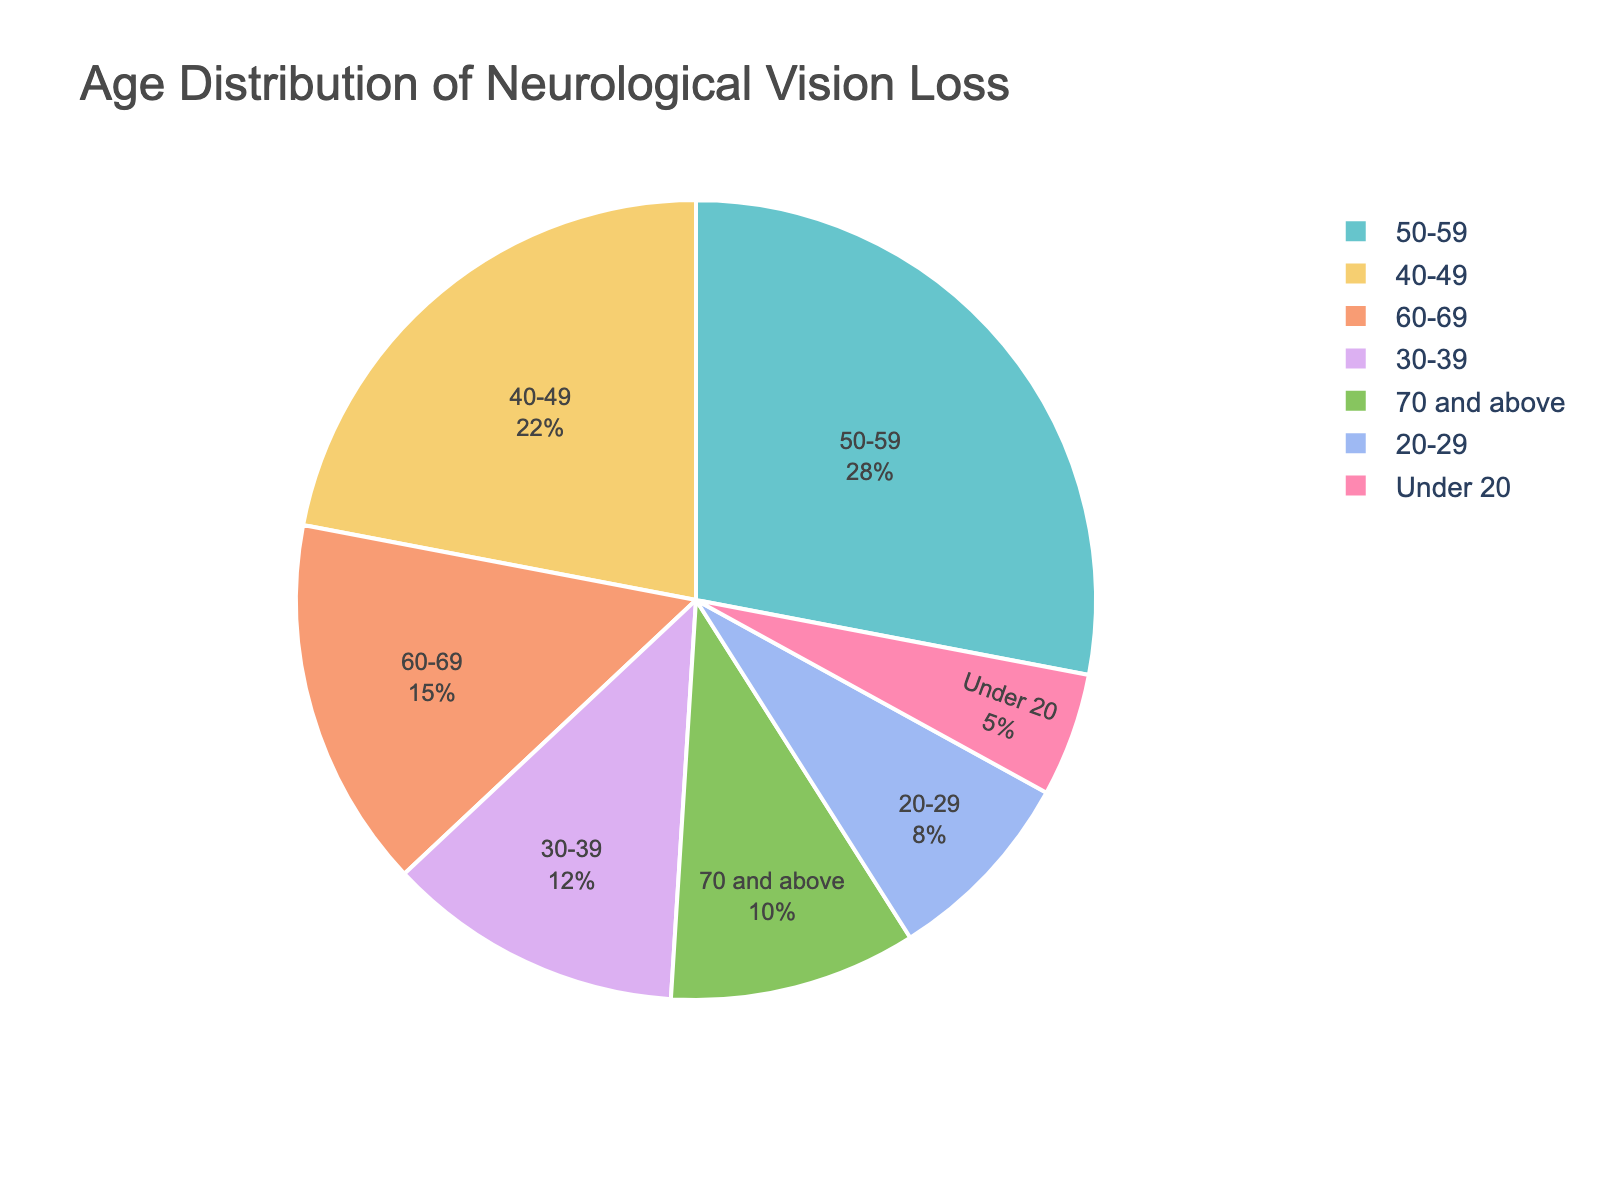What's the age group with the highest percentage of individuals experiencing neurological vision loss? Looking at the pie chart, the age group with the largest sector represents the group with the highest percentage.
Answer: 50-59 What is the combined percentage of individuals aged under 40 experiencing neurological vision loss? Summing up the percentages of the age groups Under 20, 20-29, and 30-39: 5% + 8% + 12%. The combined percentage is 25%.
Answer: 25% How does the percentage of individuals aged 60-69 compare to those aged 70 and above? From the pie chart, the percentages are 15% for 60-69 and 10% for 70 and above. 15% is greater than 10%.
Answer: 15% > 10% What is the difference in the percentage of individuals in the 40-49 and 50-59 age groups experiencing neurological vision loss? Subtract the percentage of the 40-49 age group from the 50-59 age group: 28% - 22%. The difference is 6%.
Answer: 6% What percentage of individuals aged 50 and above experience neurological vision loss? Adding the percentages of the age groups 50-59, 60-69, and 70 and above: 28% + 15% + 10%. The combined percentage is 53%.
Answer: 53% 